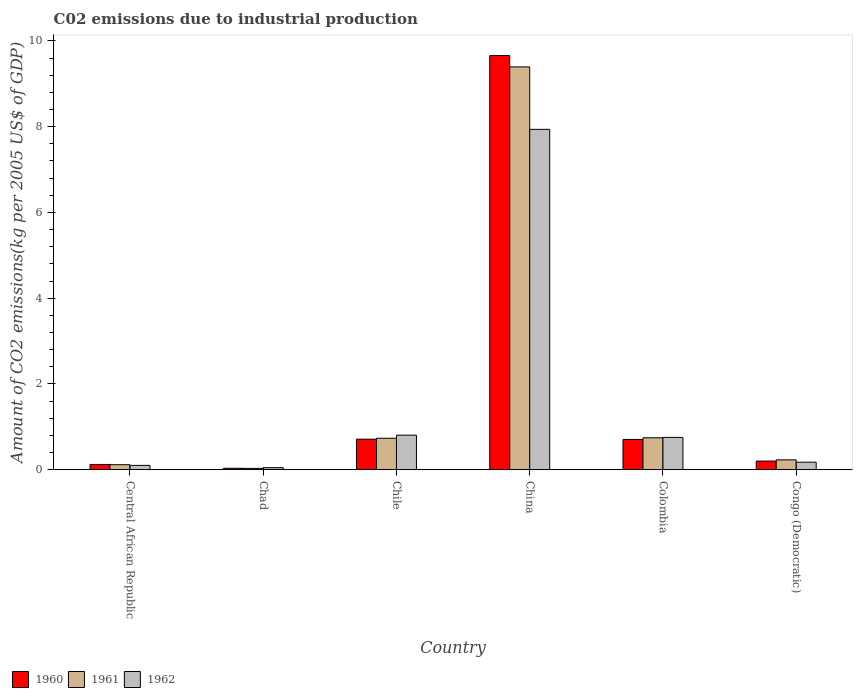How many different coloured bars are there?
Make the answer very short. 3. Are the number of bars per tick equal to the number of legend labels?
Make the answer very short. Yes. Are the number of bars on each tick of the X-axis equal?
Make the answer very short. Yes. How many bars are there on the 1st tick from the left?
Provide a short and direct response. 3. How many bars are there on the 1st tick from the right?
Your answer should be very brief. 3. In how many cases, is the number of bars for a given country not equal to the number of legend labels?
Your response must be concise. 0. What is the amount of CO2 emitted due to industrial production in 1962 in China?
Offer a terse response. 7.94. Across all countries, what is the maximum amount of CO2 emitted due to industrial production in 1960?
Your response must be concise. 9.66. Across all countries, what is the minimum amount of CO2 emitted due to industrial production in 1961?
Give a very brief answer. 0.03. In which country was the amount of CO2 emitted due to industrial production in 1962 maximum?
Make the answer very short. China. In which country was the amount of CO2 emitted due to industrial production in 1960 minimum?
Your answer should be compact. Chad. What is the total amount of CO2 emitted due to industrial production in 1960 in the graph?
Your answer should be compact. 11.43. What is the difference between the amount of CO2 emitted due to industrial production in 1962 in Chile and that in Congo (Democratic)?
Provide a succinct answer. 0.63. What is the difference between the amount of CO2 emitted due to industrial production in 1961 in Chile and the amount of CO2 emitted due to industrial production in 1960 in Congo (Democratic)?
Offer a terse response. 0.53. What is the average amount of CO2 emitted due to industrial production in 1961 per country?
Offer a terse response. 1.87. What is the difference between the amount of CO2 emitted due to industrial production of/in 1960 and amount of CO2 emitted due to industrial production of/in 1961 in Chad?
Give a very brief answer. 0. What is the ratio of the amount of CO2 emitted due to industrial production in 1961 in China to that in Congo (Democratic)?
Keep it short and to the point. 40.88. Is the amount of CO2 emitted due to industrial production in 1961 in Central African Republic less than that in Chad?
Keep it short and to the point. No. What is the difference between the highest and the second highest amount of CO2 emitted due to industrial production in 1961?
Keep it short and to the point. -8.65. What is the difference between the highest and the lowest amount of CO2 emitted due to industrial production in 1962?
Your answer should be very brief. 7.89. In how many countries, is the amount of CO2 emitted due to industrial production in 1962 greater than the average amount of CO2 emitted due to industrial production in 1962 taken over all countries?
Keep it short and to the point. 1. Is the sum of the amount of CO2 emitted due to industrial production in 1961 in Chad and China greater than the maximum amount of CO2 emitted due to industrial production in 1960 across all countries?
Offer a very short reply. No. What does the 3rd bar from the right in Chad represents?
Give a very brief answer. 1960. How many bars are there?
Provide a succinct answer. 18. How many countries are there in the graph?
Your response must be concise. 6. Are the values on the major ticks of Y-axis written in scientific E-notation?
Your answer should be very brief. No. Does the graph contain any zero values?
Your response must be concise. No. Does the graph contain grids?
Your answer should be compact. No. How many legend labels are there?
Make the answer very short. 3. What is the title of the graph?
Give a very brief answer. C02 emissions due to industrial production. What is the label or title of the X-axis?
Give a very brief answer. Country. What is the label or title of the Y-axis?
Provide a succinct answer. Amount of CO2 emissions(kg per 2005 US$ of GDP). What is the Amount of CO2 emissions(kg per 2005 US$ of GDP) of 1960 in Central African Republic?
Make the answer very short. 0.12. What is the Amount of CO2 emissions(kg per 2005 US$ of GDP) in 1961 in Central African Republic?
Offer a terse response. 0.12. What is the Amount of CO2 emissions(kg per 2005 US$ of GDP) of 1962 in Central African Republic?
Offer a terse response. 0.1. What is the Amount of CO2 emissions(kg per 2005 US$ of GDP) of 1960 in Chad?
Give a very brief answer. 0.03. What is the Amount of CO2 emissions(kg per 2005 US$ of GDP) in 1961 in Chad?
Your answer should be very brief. 0.03. What is the Amount of CO2 emissions(kg per 2005 US$ of GDP) of 1962 in Chad?
Offer a very short reply. 0.05. What is the Amount of CO2 emissions(kg per 2005 US$ of GDP) in 1960 in Chile?
Provide a short and direct response. 0.71. What is the Amount of CO2 emissions(kg per 2005 US$ of GDP) of 1961 in Chile?
Your answer should be compact. 0.73. What is the Amount of CO2 emissions(kg per 2005 US$ of GDP) in 1962 in Chile?
Your response must be concise. 0.81. What is the Amount of CO2 emissions(kg per 2005 US$ of GDP) of 1960 in China?
Give a very brief answer. 9.66. What is the Amount of CO2 emissions(kg per 2005 US$ of GDP) in 1961 in China?
Keep it short and to the point. 9.39. What is the Amount of CO2 emissions(kg per 2005 US$ of GDP) of 1962 in China?
Make the answer very short. 7.94. What is the Amount of CO2 emissions(kg per 2005 US$ of GDP) of 1960 in Colombia?
Offer a terse response. 0.71. What is the Amount of CO2 emissions(kg per 2005 US$ of GDP) of 1961 in Colombia?
Offer a terse response. 0.74. What is the Amount of CO2 emissions(kg per 2005 US$ of GDP) of 1962 in Colombia?
Your answer should be very brief. 0.75. What is the Amount of CO2 emissions(kg per 2005 US$ of GDP) in 1960 in Congo (Democratic)?
Your answer should be very brief. 0.2. What is the Amount of CO2 emissions(kg per 2005 US$ of GDP) in 1961 in Congo (Democratic)?
Your answer should be very brief. 0.23. What is the Amount of CO2 emissions(kg per 2005 US$ of GDP) of 1962 in Congo (Democratic)?
Keep it short and to the point. 0.17. Across all countries, what is the maximum Amount of CO2 emissions(kg per 2005 US$ of GDP) of 1960?
Provide a succinct answer. 9.66. Across all countries, what is the maximum Amount of CO2 emissions(kg per 2005 US$ of GDP) of 1961?
Your answer should be very brief. 9.39. Across all countries, what is the maximum Amount of CO2 emissions(kg per 2005 US$ of GDP) in 1962?
Offer a very short reply. 7.94. Across all countries, what is the minimum Amount of CO2 emissions(kg per 2005 US$ of GDP) of 1960?
Make the answer very short. 0.03. Across all countries, what is the minimum Amount of CO2 emissions(kg per 2005 US$ of GDP) of 1961?
Offer a terse response. 0.03. Across all countries, what is the minimum Amount of CO2 emissions(kg per 2005 US$ of GDP) of 1962?
Provide a succinct answer. 0.05. What is the total Amount of CO2 emissions(kg per 2005 US$ of GDP) in 1960 in the graph?
Offer a terse response. 11.43. What is the total Amount of CO2 emissions(kg per 2005 US$ of GDP) in 1961 in the graph?
Offer a very short reply. 11.25. What is the total Amount of CO2 emissions(kg per 2005 US$ of GDP) in 1962 in the graph?
Your answer should be very brief. 9.82. What is the difference between the Amount of CO2 emissions(kg per 2005 US$ of GDP) of 1960 in Central African Republic and that in Chad?
Provide a succinct answer. 0.09. What is the difference between the Amount of CO2 emissions(kg per 2005 US$ of GDP) of 1961 in Central African Republic and that in Chad?
Ensure brevity in your answer.  0.09. What is the difference between the Amount of CO2 emissions(kg per 2005 US$ of GDP) in 1962 in Central African Republic and that in Chad?
Provide a succinct answer. 0.05. What is the difference between the Amount of CO2 emissions(kg per 2005 US$ of GDP) of 1960 in Central African Republic and that in Chile?
Provide a succinct answer. -0.59. What is the difference between the Amount of CO2 emissions(kg per 2005 US$ of GDP) of 1961 in Central African Republic and that in Chile?
Provide a succinct answer. -0.62. What is the difference between the Amount of CO2 emissions(kg per 2005 US$ of GDP) in 1962 in Central African Republic and that in Chile?
Offer a terse response. -0.71. What is the difference between the Amount of CO2 emissions(kg per 2005 US$ of GDP) of 1960 in Central African Republic and that in China?
Offer a terse response. -9.54. What is the difference between the Amount of CO2 emissions(kg per 2005 US$ of GDP) of 1961 in Central African Republic and that in China?
Your response must be concise. -9.28. What is the difference between the Amount of CO2 emissions(kg per 2005 US$ of GDP) in 1962 in Central African Republic and that in China?
Make the answer very short. -7.84. What is the difference between the Amount of CO2 emissions(kg per 2005 US$ of GDP) of 1960 in Central African Republic and that in Colombia?
Your answer should be compact. -0.58. What is the difference between the Amount of CO2 emissions(kg per 2005 US$ of GDP) of 1961 in Central African Republic and that in Colombia?
Your answer should be compact. -0.63. What is the difference between the Amount of CO2 emissions(kg per 2005 US$ of GDP) in 1962 in Central African Republic and that in Colombia?
Offer a terse response. -0.65. What is the difference between the Amount of CO2 emissions(kg per 2005 US$ of GDP) in 1960 in Central African Republic and that in Congo (Democratic)?
Give a very brief answer. -0.08. What is the difference between the Amount of CO2 emissions(kg per 2005 US$ of GDP) of 1961 in Central African Republic and that in Congo (Democratic)?
Your answer should be compact. -0.11. What is the difference between the Amount of CO2 emissions(kg per 2005 US$ of GDP) of 1962 in Central African Republic and that in Congo (Democratic)?
Offer a very short reply. -0.07. What is the difference between the Amount of CO2 emissions(kg per 2005 US$ of GDP) in 1960 in Chad and that in Chile?
Your response must be concise. -0.68. What is the difference between the Amount of CO2 emissions(kg per 2005 US$ of GDP) in 1961 in Chad and that in Chile?
Your answer should be compact. -0.7. What is the difference between the Amount of CO2 emissions(kg per 2005 US$ of GDP) of 1962 in Chad and that in Chile?
Provide a succinct answer. -0.76. What is the difference between the Amount of CO2 emissions(kg per 2005 US$ of GDP) of 1960 in Chad and that in China?
Provide a succinct answer. -9.62. What is the difference between the Amount of CO2 emissions(kg per 2005 US$ of GDP) in 1961 in Chad and that in China?
Give a very brief answer. -9.36. What is the difference between the Amount of CO2 emissions(kg per 2005 US$ of GDP) of 1962 in Chad and that in China?
Ensure brevity in your answer.  -7.89. What is the difference between the Amount of CO2 emissions(kg per 2005 US$ of GDP) in 1960 in Chad and that in Colombia?
Keep it short and to the point. -0.67. What is the difference between the Amount of CO2 emissions(kg per 2005 US$ of GDP) in 1961 in Chad and that in Colombia?
Offer a very short reply. -0.71. What is the difference between the Amount of CO2 emissions(kg per 2005 US$ of GDP) in 1962 in Chad and that in Colombia?
Ensure brevity in your answer.  -0.71. What is the difference between the Amount of CO2 emissions(kg per 2005 US$ of GDP) in 1960 in Chad and that in Congo (Democratic)?
Ensure brevity in your answer.  -0.17. What is the difference between the Amount of CO2 emissions(kg per 2005 US$ of GDP) of 1961 in Chad and that in Congo (Democratic)?
Offer a very short reply. -0.2. What is the difference between the Amount of CO2 emissions(kg per 2005 US$ of GDP) in 1962 in Chad and that in Congo (Democratic)?
Give a very brief answer. -0.13. What is the difference between the Amount of CO2 emissions(kg per 2005 US$ of GDP) of 1960 in Chile and that in China?
Make the answer very short. -8.95. What is the difference between the Amount of CO2 emissions(kg per 2005 US$ of GDP) in 1961 in Chile and that in China?
Offer a terse response. -8.66. What is the difference between the Amount of CO2 emissions(kg per 2005 US$ of GDP) in 1962 in Chile and that in China?
Your answer should be very brief. -7.13. What is the difference between the Amount of CO2 emissions(kg per 2005 US$ of GDP) in 1960 in Chile and that in Colombia?
Your response must be concise. 0.01. What is the difference between the Amount of CO2 emissions(kg per 2005 US$ of GDP) of 1961 in Chile and that in Colombia?
Ensure brevity in your answer.  -0.01. What is the difference between the Amount of CO2 emissions(kg per 2005 US$ of GDP) of 1962 in Chile and that in Colombia?
Keep it short and to the point. 0.05. What is the difference between the Amount of CO2 emissions(kg per 2005 US$ of GDP) of 1960 in Chile and that in Congo (Democratic)?
Offer a terse response. 0.51. What is the difference between the Amount of CO2 emissions(kg per 2005 US$ of GDP) of 1961 in Chile and that in Congo (Democratic)?
Your answer should be compact. 0.5. What is the difference between the Amount of CO2 emissions(kg per 2005 US$ of GDP) in 1962 in Chile and that in Congo (Democratic)?
Keep it short and to the point. 0.63. What is the difference between the Amount of CO2 emissions(kg per 2005 US$ of GDP) in 1960 in China and that in Colombia?
Provide a short and direct response. 8.95. What is the difference between the Amount of CO2 emissions(kg per 2005 US$ of GDP) of 1961 in China and that in Colombia?
Keep it short and to the point. 8.65. What is the difference between the Amount of CO2 emissions(kg per 2005 US$ of GDP) in 1962 in China and that in Colombia?
Make the answer very short. 7.18. What is the difference between the Amount of CO2 emissions(kg per 2005 US$ of GDP) of 1960 in China and that in Congo (Democratic)?
Offer a terse response. 9.46. What is the difference between the Amount of CO2 emissions(kg per 2005 US$ of GDP) in 1961 in China and that in Congo (Democratic)?
Offer a very short reply. 9.16. What is the difference between the Amount of CO2 emissions(kg per 2005 US$ of GDP) in 1962 in China and that in Congo (Democratic)?
Provide a short and direct response. 7.76. What is the difference between the Amount of CO2 emissions(kg per 2005 US$ of GDP) of 1960 in Colombia and that in Congo (Democratic)?
Keep it short and to the point. 0.5. What is the difference between the Amount of CO2 emissions(kg per 2005 US$ of GDP) of 1961 in Colombia and that in Congo (Democratic)?
Your answer should be very brief. 0.51. What is the difference between the Amount of CO2 emissions(kg per 2005 US$ of GDP) of 1962 in Colombia and that in Congo (Democratic)?
Offer a very short reply. 0.58. What is the difference between the Amount of CO2 emissions(kg per 2005 US$ of GDP) of 1960 in Central African Republic and the Amount of CO2 emissions(kg per 2005 US$ of GDP) of 1961 in Chad?
Your answer should be very brief. 0.09. What is the difference between the Amount of CO2 emissions(kg per 2005 US$ of GDP) in 1960 in Central African Republic and the Amount of CO2 emissions(kg per 2005 US$ of GDP) in 1962 in Chad?
Give a very brief answer. 0.07. What is the difference between the Amount of CO2 emissions(kg per 2005 US$ of GDP) in 1961 in Central African Republic and the Amount of CO2 emissions(kg per 2005 US$ of GDP) in 1962 in Chad?
Make the answer very short. 0.07. What is the difference between the Amount of CO2 emissions(kg per 2005 US$ of GDP) of 1960 in Central African Republic and the Amount of CO2 emissions(kg per 2005 US$ of GDP) of 1961 in Chile?
Your answer should be very brief. -0.61. What is the difference between the Amount of CO2 emissions(kg per 2005 US$ of GDP) in 1960 in Central African Republic and the Amount of CO2 emissions(kg per 2005 US$ of GDP) in 1962 in Chile?
Offer a very short reply. -0.68. What is the difference between the Amount of CO2 emissions(kg per 2005 US$ of GDP) in 1961 in Central African Republic and the Amount of CO2 emissions(kg per 2005 US$ of GDP) in 1962 in Chile?
Offer a terse response. -0.69. What is the difference between the Amount of CO2 emissions(kg per 2005 US$ of GDP) of 1960 in Central African Republic and the Amount of CO2 emissions(kg per 2005 US$ of GDP) of 1961 in China?
Your answer should be compact. -9.27. What is the difference between the Amount of CO2 emissions(kg per 2005 US$ of GDP) in 1960 in Central African Republic and the Amount of CO2 emissions(kg per 2005 US$ of GDP) in 1962 in China?
Provide a short and direct response. -7.82. What is the difference between the Amount of CO2 emissions(kg per 2005 US$ of GDP) of 1961 in Central African Republic and the Amount of CO2 emissions(kg per 2005 US$ of GDP) of 1962 in China?
Offer a terse response. -7.82. What is the difference between the Amount of CO2 emissions(kg per 2005 US$ of GDP) of 1960 in Central African Republic and the Amount of CO2 emissions(kg per 2005 US$ of GDP) of 1961 in Colombia?
Your response must be concise. -0.62. What is the difference between the Amount of CO2 emissions(kg per 2005 US$ of GDP) of 1960 in Central African Republic and the Amount of CO2 emissions(kg per 2005 US$ of GDP) of 1962 in Colombia?
Make the answer very short. -0.63. What is the difference between the Amount of CO2 emissions(kg per 2005 US$ of GDP) of 1961 in Central African Republic and the Amount of CO2 emissions(kg per 2005 US$ of GDP) of 1962 in Colombia?
Offer a very short reply. -0.64. What is the difference between the Amount of CO2 emissions(kg per 2005 US$ of GDP) in 1960 in Central African Republic and the Amount of CO2 emissions(kg per 2005 US$ of GDP) in 1961 in Congo (Democratic)?
Your answer should be very brief. -0.11. What is the difference between the Amount of CO2 emissions(kg per 2005 US$ of GDP) of 1960 in Central African Republic and the Amount of CO2 emissions(kg per 2005 US$ of GDP) of 1962 in Congo (Democratic)?
Give a very brief answer. -0.05. What is the difference between the Amount of CO2 emissions(kg per 2005 US$ of GDP) in 1961 in Central African Republic and the Amount of CO2 emissions(kg per 2005 US$ of GDP) in 1962 in Congo (Democratic)?
Give a very brief answer. -0.06. What is the difference between the Amount of CO2 emissions(kg per 2005 US$ of GDP) in 1960 in Chad and the Amount of CO2 emissions(kg per 2005 US$ of GDP) in 1961 in Chile?
Offer a very short reply. -0.7. What is the difference between the Amount of CO2 emissions(kg per 2005 US$ of GDP) of 1960 in Chad and the Amount of CO2 emissions(kg per 2005 US$ of GDP) of 1962 in Chile?
Offer a very short reply. -0.77. What is the difference between the Amount of CO2 emissions(kg per 2005 US$ of GDP) of 1961 in Chad and the Amount of CO2 emissions(kg per 2005 US$ of GDP) of 1962 in Chile?
Offer a very short reply. -0.78. What is the difference between the Amount of CO2 emissions(kg per 2005 US$ of GDP) of 1960 in Chad and the Amount of CO2 emissions(kg per 2005 US$ of GDP) of 1961 in China?
Your response must be concise. -9.36. What is the difference between the Amount of CO2 emissions(kg per 2005 US$ of GDP) in 1960 in Chad and the Amount of CO2 emissions(kg per 2005 US$ of GDP) in 1962 in China?
Offer a terse response. -7.9. What is the difference between the Amount of CO2 emissions(kg per 2005 US$ of GDP) of 1961 in Chad and the Amount of CO2 emissions(kg per 2005 US$ of GDP) of 1962 in China?
Your answer should be compact. -7.91. What is the difference between the Amount of CO2 emissions(kg per 2005 US$ of GDP) in 1960 in Chad and the Amount of CO2 emissions(kg per 2005 US$ of GDP) in 1961 in Colombia?
Your answer should be very brief. -0.71. What is the difference between the Amount of CO2 emissions(kg per 2005 US$ of GDP) in 1960 in Chad and the Amount of CO2 emissions(kg per 2005 US$ of GDP) in 1962 in Colombia?
Give a very brief answer. -0.72. What is the difference between the Amount of CO2 emissions(kg per 2005 US$ of GDP) in 1961 in Chad and the Amount of CO2 emissions(kg per 2005 US$ of GDP) in 1962 in Colombia?
Offer a very short reply. -0.72. What is the difference between the Amount of CO2 emissions(kg per 2005 US$ of GDP) of 1960 in Chad and the Amount of CO2 emissions(kg per 2005 US$ of GDP) of 1961 in Congo (Democratic)?
Your response must be concise. -0.2. What is the difference between the Amount of CO2 emissions(kg per 2005 US$ of GDP) in 1960 in Chad and the Amount of CO2 emissions(kg per 2005 US$ of GDP) in 1962 in Congo (Democratic)?
Provide a short and direct response. -0.14. What is the difference between the Amount of CO2 emissions(kg per 2005 US$ of GDP) in 1961 in Chad and the Amount of CO2 emissions(kg per 2005 US$ of GDP) in 1962 in Congo (Democratic)?
Give a very brief answer. -0.14. What is the difference between the Amount of CO2 emissions(kg per 2005 US$ of GDP) of 1960 in Chile and the Amount of CO2 emissions(kg per 2005 US$ of GDP) of 1961 in China?
Make the answer very short. -8.68. What is the difference between the Amount of CO2 emissions(kg per 2005 US$ of GDP) in 1960 in Chile and the Amount of CO2 emissions(kg per 2005 US$ of GDP) in 1962 in China?
Your answer should be very brief. -7.23. What is the difference between the Amount of CO2 emissions(kg per 2005 US$ of GDP) of 1961 in Chile and the Amount of CO2 emissions(kg per 2005 US$ of GDP) of 1962 in China?
Keep it short and to the point. -7.2. What is the difference between the Amount of CO2 emissions(kg per 2005 US$ of GDP) of 1960 in Chile and the Amount of CO2 emissions(kg per 2005 US$ of GDP) of 1961 in Colombia?
Make the answer very short. -0.03. What is the difference between the Amount of CO2 emissions(kg per 2005 US$ of GDP) of 1960 in Chile and the Amount of CO2 emissions(kg per 2005 US$ of GDP) of 1962 in Colombia?
Offer a very short reply. -0.04. What is the difference between the Amount of CO2 emissions(kg per 2005 US$ of GDP) of 1961 in Chile and the Amount of CO2 emissions(kg per 2005 US$ of GDP) of 1962 in Colombia?
Your answer should be compact. -0.02. What is the difference between the Amount of CO2 emissions(kg per 2005 US$ of GDP) of 1960 in Chile and the Amount of CO2 emissions(kg per 2005 US$ of GDP) of 1961 in Congo (Democratic)?
Your answer should be compact. 0.48. What is the difference between the Amount of CO2 emissions(kg per 2005 US$ of GDP) of 1960 in Chile and the Amount of CO2 emissions(kg per 2005 US$ of GDP) of 1962 in Congo (Democratic)?
Offer a terse response. 0.54. What is the difference between the Amount of CO2 emissions(kg per 2005 US$ of GDP) of 1961 in Chile and the Amount of CO2 emissions(kg per 2005 US$ of GDP) of 1962 in Congo (Democratic)?
Keep it short and to the point. 0.56. What is the difference between the Amount of CO2 emissions(kg per 2005 US$ of GDP) of 1960 in China and the Amount of CO2 emissions(kg per 2005 US$ of GDP) of 1961 in Colombia?
Your response must be concise. 8.91. What is the difference between the Amount of CO2 emissions(kg per 2005 US$ of GDP) of 1960 in China and the Amount of CO2 emissions(kg per 2005 US$ of GDP) of 1962 in Colombia?
Give a very brief answer. 8.9. What is the difference between the Amount of CO2 emissions(kg per 2005 US$ of GDP) in 1961 in China and the Amount of CO2 emissions(kg per 2005 US$ of GDP) in 1962 in Colombia?
Give a very brief answer. 8.64. What is the difference between the Amount of CO2 emissions(kg per 2005 US$ of GDP) of 1960 in China and the Amount of CO2 emissions(kg per 2005 US$ of GDP) of 1961 in Congo (Democratic)?
Offer a terse response. 9.43. What is the difference between the Amount of CO2 emissions(kg per 2005 US$ of GDP) of 1960 in China and the Amount of CO2 emissions(kg per 2005 US$ of GDP) of 1962 in Congo (Democratic)?
Provide a short and direct response. 9.48. What is the difference between the Amount of CO2 emissions(kg per 2005 US$ of GDP) of 1961 in China and the Amount of CO2 emissions(kg per 2005 US$ of GDP) of 1962 in Congo (Democratic)?
Offer a terse response. 9.22. What is the difference between the Amount of CO2 emissions(kg per 2005 US$ of GDP) in 1960 in Colombia and the Amount of CO2 emissions(kg per 2005 US$ of GDP) in 1961 in Congo (Democratic)?
Your answer should be compact. 0.48. What is the difference between the Amount of CO2 emissions(kg per 2005 US$ of GDP) of 1960 in Colombia and the Amount of CO2 emissions(kg per 2005 US$ of GDP) of 1962 in Congo (Democratic)?
Offer a terse response. 0.53. What is the difference between the Amount of CO2 emissions(kg per 2005 US$ of GDP) of 1961 in Colombia and the Amount of CO2 emissions(kg per 2005 US$ of GDP) of 1962 in Congo (Democratic)?
Offer a terse response. 0.57. What is the average Amount of CO2 emissions(kg per 2005 US$ of GDP) of 1960 per country?
Your response must be concise. 1.91. What is the average Amount of CO2 emissions(kg per 2005 US$ of GDP) in 1961 per country?
Provide a succinct answer. 1.87. What is the average Amount of CO2 emissions(kg per 2005 US$ of GDP) in 1962 per country?
Provide a short and direct response. 1.64. What is the difference between the Amount of CO2 emissions(kg per 2005 US$ of GDP) in 1960 and Amount of CO2 emissions(kg per 2005 US$ of GDP) in 1961 in Central African Republic?
Offer a terse response. 0.01. What is the difference between the Amount of CO2 emissions(kg per 2005 US$ of GDP) of 1960 and Amount of CO2 emissions(kg per 2005 US$ of GDP) of 1962 in Central African Republic?
Keep it short and to the point. 0.02. What is the difference between the Amount of CO2 emissions(kg per 2005 US$ of GDP) in 1961 and Amount of CO2 emissions(kg per 2005 US$ of GDP) in 1962 in Central African Republic?
Give a very brief answer. 0.02. What is the difference between the Amount of CO2 emissions(kg per 2005 US$ of GDP) in 1960 and Amount of CO2 emissions(kg per 2005 US$ of GDP) in 1961 in Chad?
Offer a very short reply. 0. What is the difference between the Amount of CO2 emissions(kg per 2005 US$ of GDP) in 1960 and Amount of CO2 emissions(kg per 2005 US$ of GDP) in 1962 in Chad?
Your answer should be compact. -0.01. What is the difference between the Amount of CO2 emissions(kg per 2005 US$ of GDP) in 1961 and Amount of CO2 emissions(kg per 2005 US$ of GDP) in 1962 in Chad?
Your answer should be compact. -0.02. What is the difference between the Amount of CO2 emissions(kg per 2005 US$ of GDP) in 1960 and Amount of CO2 emissions(kg per 2005 US$ of GDP) in 1961 in Chile?
Make the answer very short. -0.02. What is the difference between the Amount of CO2 emissions(kg per 2005 US$ of GDP) of 1960 and Amount of CO2 emissions(kg per 2005 US$ of GDP) of 1962 in Chile?
Provide a short and direct response. -0.09. What is the difference between the Amount of CO2 emissions(kg per 2005 US$ of GDP) in 1961 and Amount of CO2 emissions(kg per 2005 US$ of GDP) in 1962 in Chile?
Ensure brevity in your answer.  -0.07. What is the difference between the Amount of CO2 emissions(kg per 2005 US$ of GDP) of 1960 and Amount of CO2 emissions(kg per 2005 US$ of GDP) of 1961 in China?
Provide a short and direct response. 0.26. What is the difference between the Amount of CO2 emissions(kg per 2005 US$ of GDP) of 1960 and Amount of CO2 emissions(kg per 2005 US$ of GDP) of 1962 in China?
Your answer should be very brief. 1.72. What is the difference between the Amount of CO2 emissions(kg per 2005 US$ of GDP) in 1961 and Amount of CO2 emissions(kg per 2005 US$ of GDP) in 1962 in China?
Give a very brief answer. 1.46. What is the difference between the Amount of CO2 emissions(kg per 2005 US$ of GDP) of 1960 and Amount of CO2 emissions(kg per 2005 US$ of GDP) of 1961 in Colombia?
Make the answer very short. -0.04. What is the difference between the Amount of CO2 emissions(kg per 2005 US$ of GDP) of 1960 and Amount of CO2 emissions(kg per 2005 US$ of GDP) of 1962 in Colombia?
Give a very brief answer. -0.05. What is the difference between the Amount of CO2 emissions(kg per 2005 US$ of GDP) of 1961 and Amount of CO2 emissions(kg per 2005 US$ of GDP) of 1962 in Colombia?
Keep it short and to the point. -0.01. What is the difference between the Amount of CO2 emissions(kg per 2005 US$ of GDP) in 1960 and Amount of CO2 emissions(kg per 2005 US$ of GDP) in 1961 in Congo (Democratic)?
Your answer should be very brief. -0.03. What is the difference between the Amount of CO2 emissions(kg per 2005 US$ of GDP) in 1960 and Amount of CO2 emissions(kg per 2005 US$ of GDP) in 1962 in Congo (Democratic)?
Your response must be concise. 0.03. What is the difference between the Amount of CO2 emissions(kg per 2005 US$ of GDP) of 1961 and Amount of CO2 emissions(kg per 2005 US$ of GDP) of 1962 in Congo (Democratic)?
Make the answer very short. 0.05. What is the ratio of the Amount of CO2 emissions(kg per 2005 US$ of GDP) in 1960 in Central African Republic to that in Chad?
Keep it short and to the point. 3.67. What is the ratio of the Amount of CO2 emissions(kg per 2005 US$ of GDP) of 1961 in Central African Republic to that in Chad?
Provide a succinct answer. 3.79. What is the ratio of the Amount of CO2 emissions(kg per 2005 US$ of GDP) of 1962 in Central African Republic to that in Chad?
Provide a short and direct response. 2.11. What is the ratio of the Amount of CO2 emissions(kg per 2005 US$ of GDP) in 1960 in Central African Republic to that in Chile?
Your answer should be compact. 0.17. What is the ratio of the Amount of CO2 emissions(kg per 2005 US$ of GDP) in 1961 in Central African Republic to that in Chile?
Your answer should be compact. 0.16. What is the ratio of the Amount of CO2 emissions(kg per 2005 US$ of GDP) of 1962 in Central African Republic to that in Chile?
Keep it short and to the point. 0.12. What is the ratio of the Amount of CO2 emissions(kg per 2005 US$ of GDP) of 1960 in Central African Republic to that in China?
Offer a very short reply. 0.01. What is the ratio of the Amount of CO2 emissions(kg per 2005 US$ of GDP) of 1961 in Central African Republic to that in China?
Offer a very short reply. 0.01. What is the ratio of the Amount of CO2 emissions(kg per 2005 US$ of GDP) of 1962 in Central African Republic to that in China?
Offer a very short reply. 0.01. What is the ratio of the Amount of CO2 emissions(kg per 2005 US$ of GDP) in 1960 in Central African Republic to that in Colombia?
Your response must be concise. 0.17. What is the ratio of the Amount of CO2 emissions(kg per 2005 US$ of GDP) in 1961 in Central African Republic to that in Colombia?
Provide a succinct answer. 0.16. What is the ratio of the Amount of CO2 emissions(kg per 2005 US$ of GDP) in 1962 in Central African Republic to that in Colombia?
Offer a very short reply. 0.13. What is the ratio of the Amount of CO2 emissions(kg per 2005 US$ of GDP) in 1960 in Central African Republic to that in Congo (Democratic)?
Provide a succinct answer. 0.61. What is the ratio of the Amount of CO2 emissions(kg per 2005 US$ of GDP) of 1961 in Central African Republic to that in Congo (Democratic)?
Provide a short and direct response. 0.51. What is the ratio of the Amount of CO2 emissions(kg per 2005 US$ of GDP) in 1962 in Central African Republic to that in Congo (Democratic)?
Provide a short and direct response. 0.58. What is the ratio of the Amount of CO2 emissions(kg per 2005 US$ of GDP) in 1960 in Chad to that in Chile?
Keep it short and to the point. 0.05. What is the ratio of the Amount of CO2 emissions(kg per 2005 US$ of GDP) in 1961 in Chad to that in Chile?
Give a very brief answer. 0.04. What is the ratio of the Amount of CO2 emissions(kg per 2005 US$ of GDP) of 1962 in Chad to that in Chile?
Give a very brief answer. 0.06. What is the ratio of the Amount of CO2 emissions(kg per 2005 US$ of GDP) in 1960 in Chad to that in China?
Provide a succinct answer. 0. What is the ratio of the Amount of CO2 emissions(kg per 2005 US$ of GDP) in 1961 in Chad to that in China?
Your answer should be compact. 0. What is the ratio of the Amount of CO2 emissions(kg per 2005 US$ of GDP) of 1962 in Chad to that in China?
Offer a terse response. 0.01. What is the ratio of the Amount of CO2 emissions(kg per 2005 US$ of GDP) in 1960 in Chad to that in Colombia?
Your answer should be compact. 0.05. What is the ratio of the Amount of CO2 emissions(kg per 2005 US$ of GDP) in 1961 in Chad to that in Colombia?
Ensure brevity in your answer.  0.04. What is the ratio of the Amount of CO2 emissions(kg per 2005 US$ of GDP) in 1962 in Chad to that in Colombia?
Provide a short and direct response. 0.06. What is the ratio of the Amount of CO2 emissions(kg per 2005 US$ of GDP) in 1960 in Chad to that in Congo (Democratic)?
Give a very brief answer. 0.17. What is the ratio of the Amount of CO2 emissions(kg per 2005 US$ of GDP) of 1961 in Chad to that in Congo (Democratic)?
Keep it short and to the point. 0.13. What is the ratio of the Amount of CO2 emissions(kg per 2005 US$ of GDP) of 1962 in Chad to that in Congo (Democratic)?
Make the answer very short. 0.27. What is the ratio of the Amount of CO2 emissions(kg per 2005 US$ of GDP) in 1960 in Chile to that in China?
Provide a short and direct response. 0.07. What is the ratio of the Amount of CO2 emissions(kg per 2005 US$ of GDP) in 1961 in Chile to that in China?
Give a very brief answer. 0.08. What is the ratio of the Amount of CO2 emissions(kg per 2005 US$ of GDP) of 1962 in Chile to that in China?
Make the answer very short. 0.1. What is the ratio of the Amount of CO2 emissions(kg per 2005 US$ of GDP) in 1960 in Chile to that in Colombia?
Provide a succinct answer. 1.01. What is the ratio of the Amount of CO2 emissions(kg per 2005 US$ of GDP) in 1961 in Chile to that in Colombia?
Offer a terse response. 0.99. What is the ratio of the Amount of CO2 emissions(kg per 2005 US$ of GDP) of 1962 in Chile to that in Colombia?
Make the answer very short. 1.07. What is the ratio of the Amount of CO2 emissions(kg per 2005 US$ of GDP) in 1960 in Chile to that in Congo (Democratic)?
Keep it short and to the point. 3.53. What is the ratio of the Amount of CO2 emissions(kg per 2005 US$ of GDP) of 1961 in Chile to that in Congo (Democratic)?
Provide a succinct answer. 3.19. What is the ratio of the Amount of CO2 emissions(kg per 2005 US$ of GDP) in 1962 in Chile to that in Congo (Democratic)?
Your answer should be very brief. 4.61. What is the ratio of the Amount of CO2 emissions(kg per 2005 US$ of GDP) of 1960 in China to that in Colombia?
Keep it short and to the point. 13.68. What is the ratio of the Amount of CO2 emissions(kg per 2005 US$ of GDP) of 1961 in China to that in Colombia?
Keep it short and to the point. 12.62. What is the ratio of the Amount of CO2 emissions(kg per 2005 US$ of GDP) of 1962 in China to that in Colombia?
Your response must be concise. 10.54. What is the ratio of the Amount of CO2 emissions(kg per 2005 US$ of GDP) in 1960 in China to that in Congo (Democratic)?
Your answer should be very brief. 47.89. What is the ratio of the Amount of CO2 emissions(kg per 2005 US$ of GDP) in 1961 in China to that in Congo (Democratic)?
Your answer should be compact. 40.88. What is the ratio of the Amount of CO2 emissions(kg per 2005 US$ of GDP) of 1962 in China to that in Congo (Democratic)?
Your answer should be compact. 45.4. What is the ratio of the Amount of CO2 emissions(kg per 2005 US$ of GDP) of 1961 in Colombia to that in Congo (Democratic)?
Provide a succinct answer. 3.24. What is the ratio of the Amount of CO2 emissions(kg per 2005 US$ of GDP) of 1962 in Colombia to that in Congo (Democratic)?
Provide a short and direct response. 4.31. What is the difference between the highest and the second highest Amount of CO2 emissions(kg per 2005 US$ of GDP) of 1960?
Offer a very short reply. 8.95. What is the difference between the highest and the second highest Amount of CO2 emissions(kg per 2005 US$ of GDP) of 1961?
Offer a terse response. 8.65. What is the difference between the highest and the second highest Amount of CO2 emissions(kg per 2005 US$ of GDP) in 1962?
Your answer should be very brief. 7.13. What is the difference between the highest and the lowest Amount of CO2 emissions(kg per 2005 US$ of GDP) of 1960?
Provide a short and direct response. 9.62. What is the difference between the highest and the lowest Amount of CO2 emissions(kg per 2005 US$ of GDP) of 1961?
Provide a short and direct response. 9.36. What is the difference between the highest and the lowest Amount of CO2 emissions(kg per 2005 US$ of GDP) of 1962?
Make the answer very short. 7.89. 